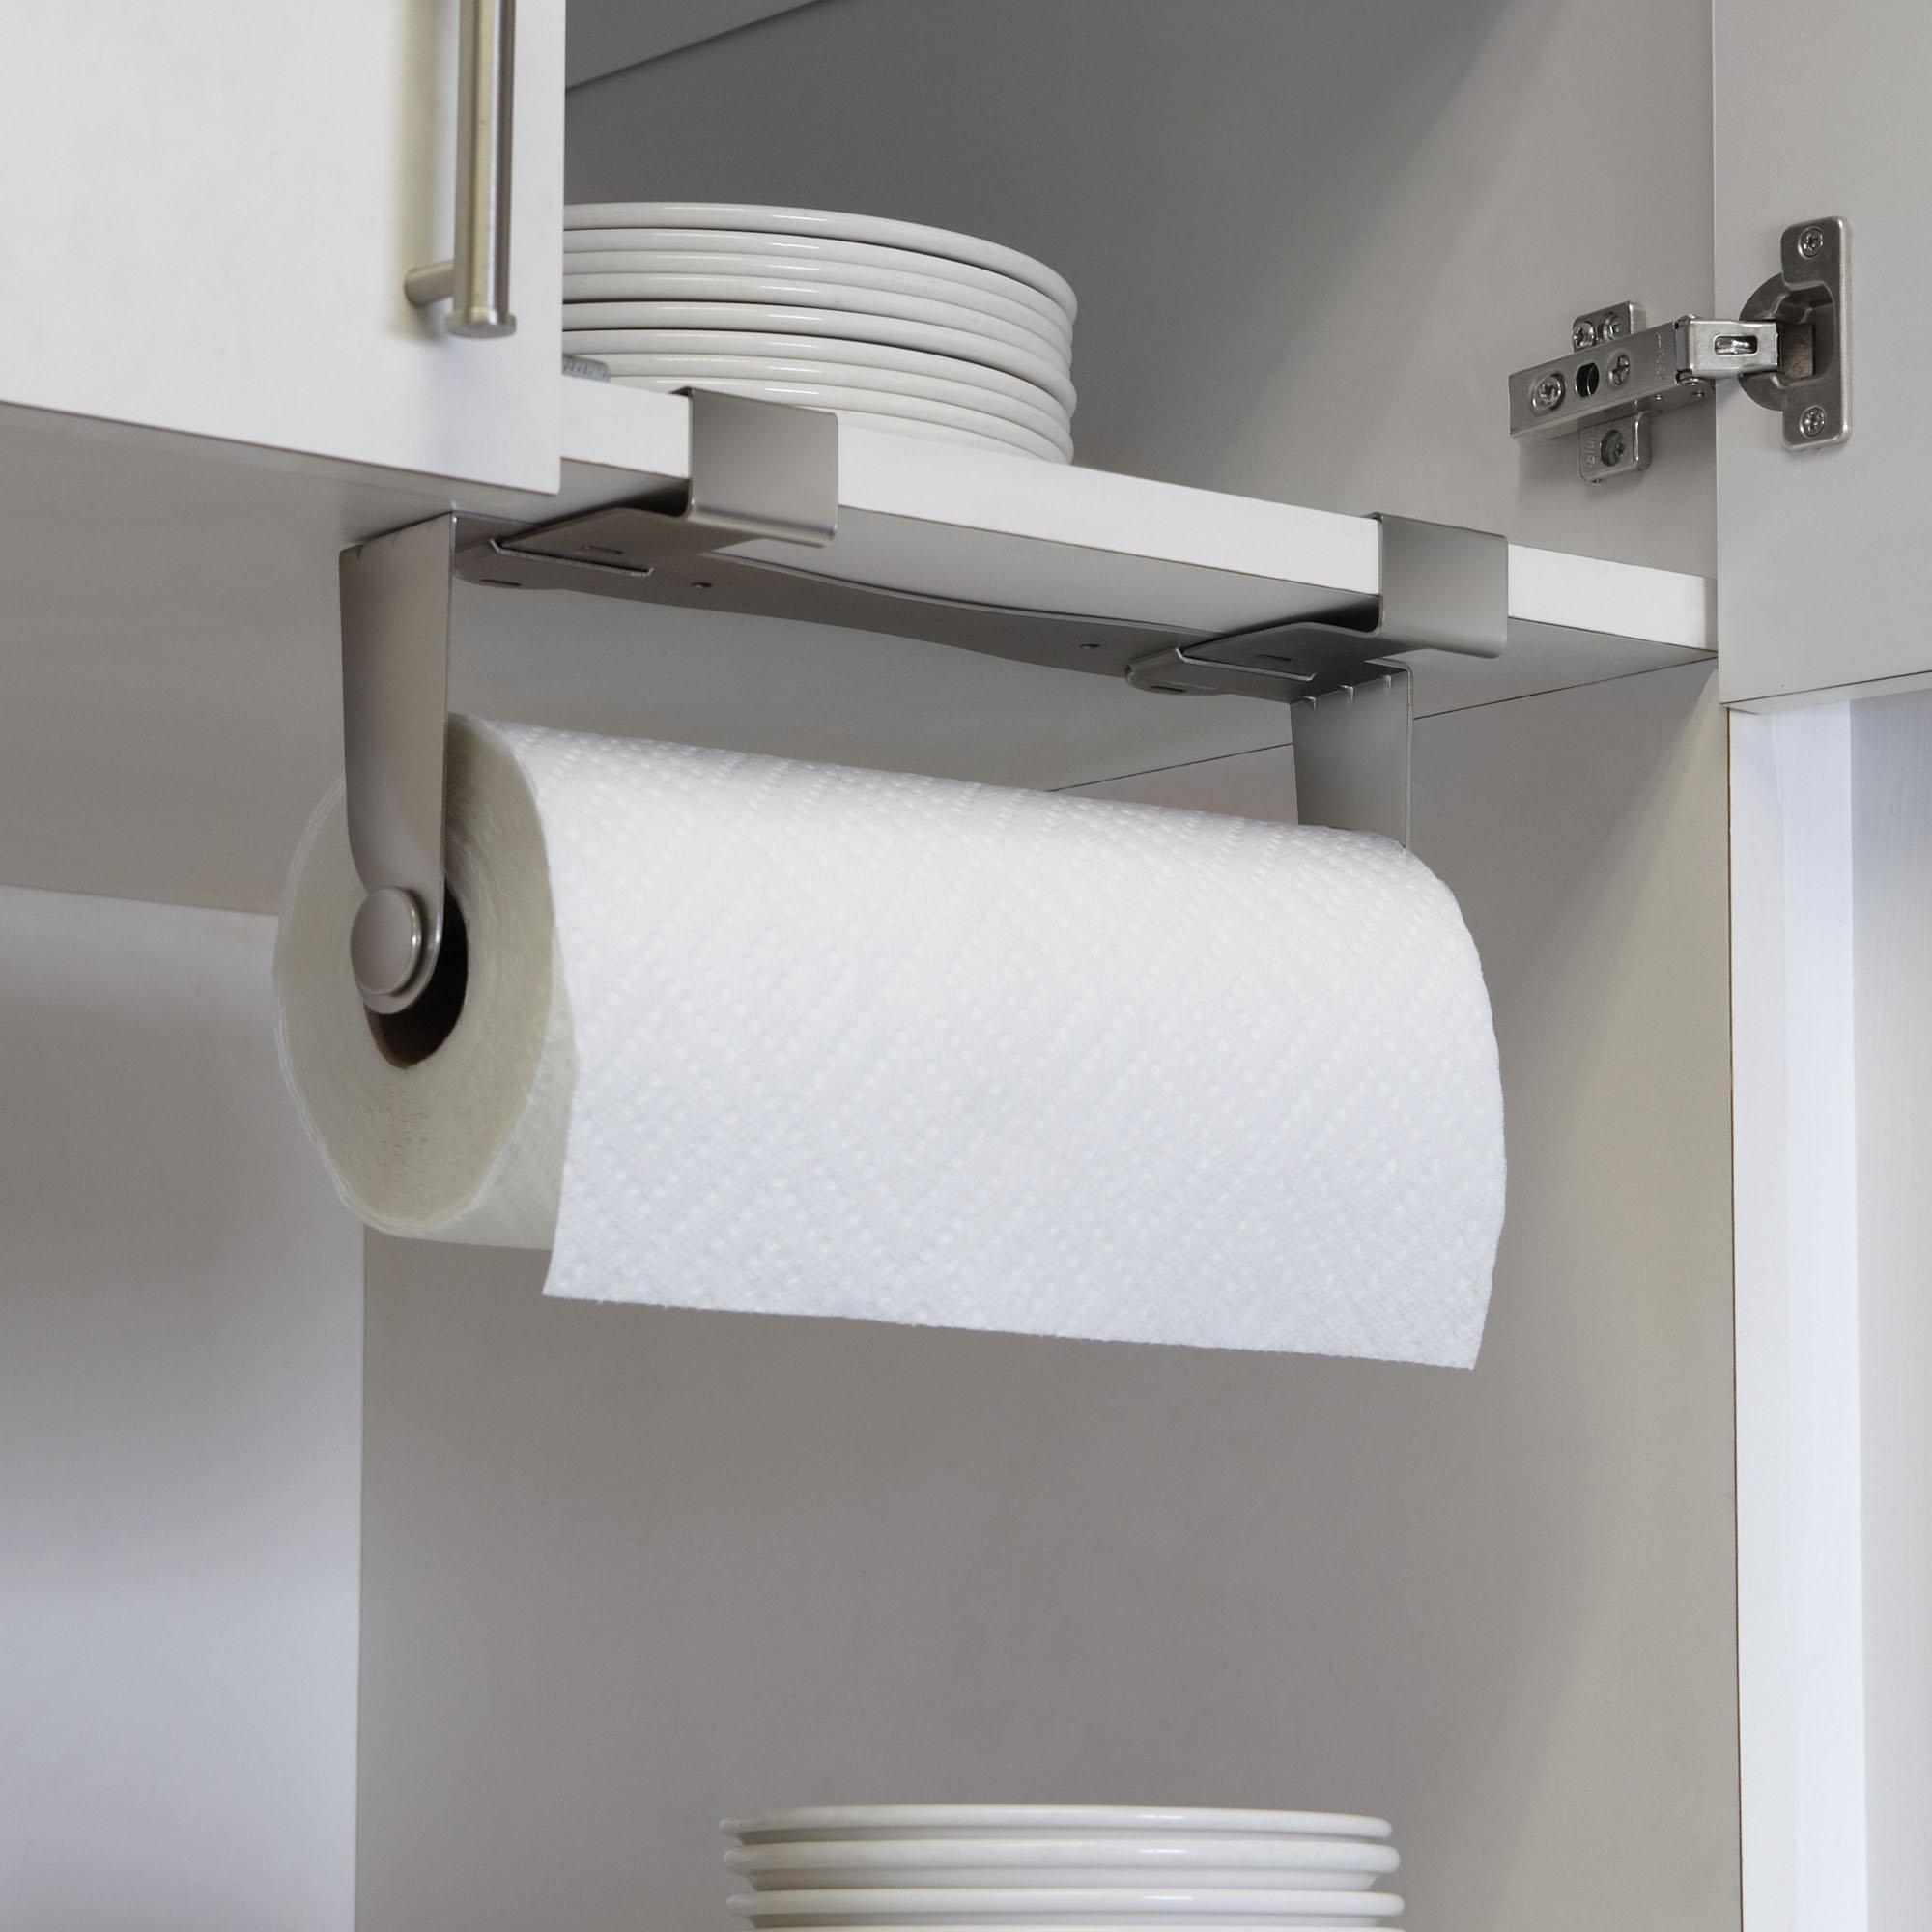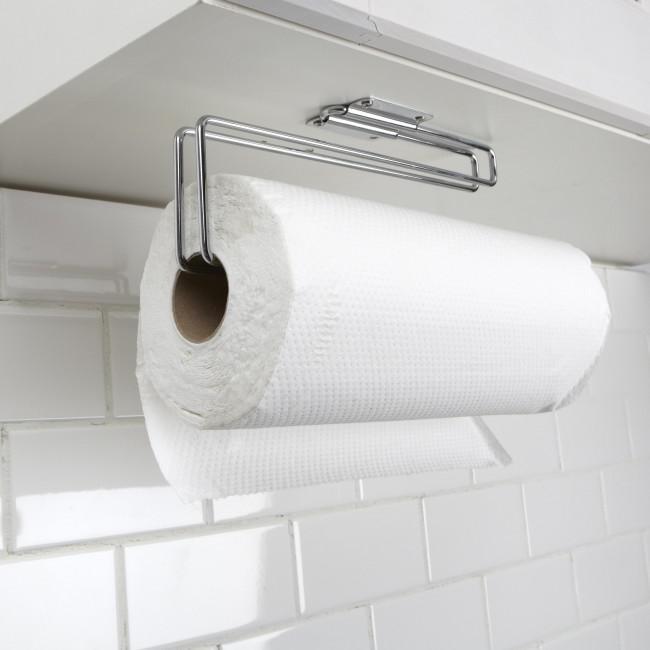The first image is the image on the left, the second image is the image on the right. Evaluate the accuracy of this statement regarding the images: "A roll of paper towels is on a rack under a cabinet with the next towel hanging from the back.". Is it true? Answer yes or no. Yes. The first image is the image on the left, the second image is the image on the right. Considering the images on both sides, is "There is at least one paper towel roll hanging" valid? Answer yes or no. Yes. 